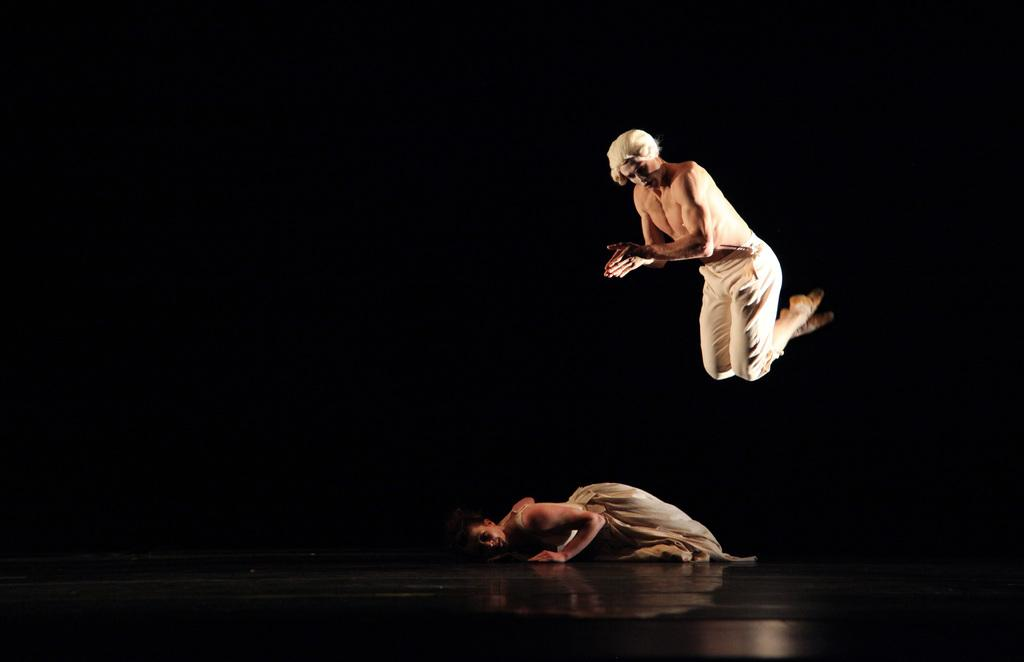What is the position of the person in the image? There is a person laying on the floor in the image. Can you describe the other person visible in the image? There is another person visible in the image. What can be observed about the background of the image? The background of the image has a dark view. What level of difficulty does the dad face in the image? There is no dad present in the image, and therefore no level of difficulty can be determined. 